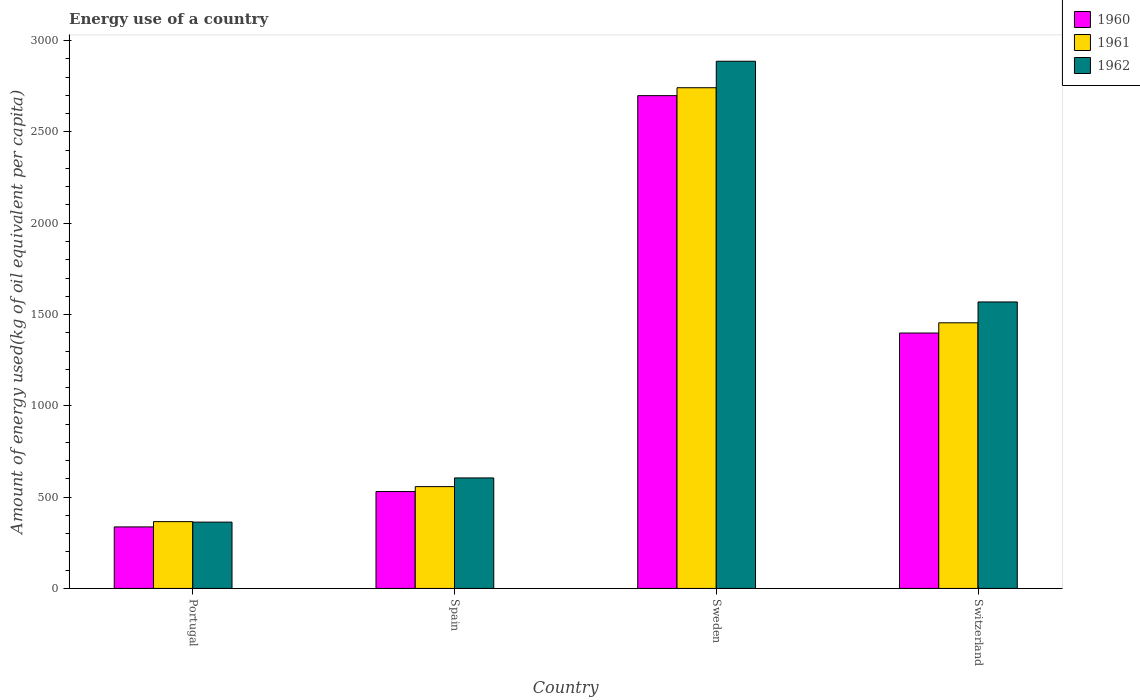What is the label of the 3rd group of bars from the left?
Offer a terse response. Sweden. In how many cases, is the number of bars for a given country not equal to the number of legend labels?
Keep it short and to the point. 0. What is the amount of energy used in in 1962 in Sweden?
Your answer should be compact. 2887.24. Across all countries, what is the maximum amount of energy used in in 1961?
Provide a succinct answer. 2742.12. Across all countries, what is the minimum amount of energy used in in 1961?
Keep it short and to the point. 365.84. What is the total amount of energy used in in 1962 in the graph?
Your answer should be compact. 5424.53. What is the difference between the amount of energy used in in 1960 in Portugal and that in Spain?
Your answer should be compact. -193.75. What is the difference between the amount of energy used in in 1960 in Sweden and the amount of energy used in in 1961 in Spain?
Your answer should be very brief. 2141.19. What is the average amount of energy used in in 1962 per country?
Give a very brief answer. 1356.13. What is the difference between the amount of energy used in of/in 1962 and amount of energy used in of/in 1960 in Portugal?
Your response must be concise. 26.25. In how many countries, is the amount of energy used in in 1960 greater than 2100 kg?
Your response must be concise. 1. What is the ratio of the amount of energy used in in 1962 in Spain to that in Switzerland?
Provide a succinct answer. 0.39. What is the difference between the highest and the second highest amount of energy used in in 1961?
Offer a very short reply. 897.16. What is the difference between the highest and the lowest amount of energy used in in 1960?
Provide a short and direct response. 2361.88. In how many countries, is the amount of energy used in in 1961 greater than the average amount of energy used in in 1961 taken over all countries?
Make the answer very short. 2. Is the sum of the amount of energy used in in 1962 in Portugal and Switzerland greater than the maximum amount of energy used in in 1961 across all countries?
Provide a succinct answer. No. What does the 2nd bar from the right in Spain represents?
Your answer should be very brief. 1961. Are all the bars in the graph horizontal?
Offer a very short reply. No. How many countries are there in the graph?
Offer a very short reply. 4. What is the difference between two consecutive major ticks on the Y-axis?
Provide a short and direct response. 500. Are the values on the major ticks of Y-axis written in scientific E-notation?
Provide a short and direct response. No. Does the graph contain grids?
Keep it short and to the point. No. How many legend labels are there?
Your answer should be compact. 3. How are the legend labels stacked?
Ensure brevity in your answer.  Vertical. What is the title of the graph?
Your response must be concise. Energy use of a country. Does "1968" appear as one of the legend labels in the graph?
Make the answer very short. No. What is the label or title of the X-axis?
Keep it short and to the point. Country. What is the label or title of the Y-axis?
Provide a succinct answer. Amount of energy used(kg of oil equivalent per capita). What is the Amount of energy used(kg of oil equivalent per capita) in 1960 in Portugal?
Your response must be concise. 336.91. What is the Amount of energy used(kg of oil equivalent per capita) of 1961 in Portugal?
Your answer should be compact. 365.84. What is the Amount of energy used(kg of oil equivalent per capita) of 1962 in Portugal?
Your response must be concise. 363.16. What is the Amount of energy used(kg of oil equivalent per capita) of 1960 in Spain?
Provide a succinct answer. 530.66. What is the Amount of energy used(kg of oil equivalent per capita) in 1961 in Spain?
Your response must be concise. 557.6. What is the Amount of energy used(kg of oil equivalent per capita) of 1962 in Spain?
Your answer should be compact. 605.22. What is the Amount of energy used(kg of oil equivalent per capita) of 1960 in Sweden?
Give a very brief answer. 2698.79. What is the Amount of energy used(kg of oil equivalent per capita) in 1961 in Sweden?
Offer a very short reply. 2742.12. What is the Amount of energy used(kg of oil equivalent per capita) of 1962 in Sweden?
Offer a terse response. 2887.24. What is the Amount of energy used(kg of oil equivalent per capita) in 1960 in Switzerland?
Offer a terse response. 1398.65. What is the Amount of energy used(kg of oil equivalent per capita) in 1961 in Switzerland?
Your answer should be very brief. 1454.76. What is the Amount of energy used(kg of oil equivalent per capita) in 1962 in Switzerland?
Keep it short and to the point. 1568.91. Across all countries, what is the maximum Amount of energy used(kg of oil equivalent per capita) of 1960?
Offer a very short reply. 2698.79. Across all countries, what is the maximum Amount of energy used(kg of oil equivalent per capita) in 1961?
Give a very brief answer. 2742.12. Across all countries, what is the maximum Amount of energy used(kg of oil equivalent per capita) of 1962?
Your response must be concise. 2887.24. Across all countries, what is the minimum Amount of energy used(kg of oil equivalent per capita) in 1960?
Your answer should be compact. 336.91. Across all countries, what is the minimum Amount of energy used(kg of oil equivalent per capita) in 1961?
Make the answer very short. 365.84. Across all countries, what is the minimum Amount of energy used(kg of oil equivalent per capita) in 1962?
Give a very brief answer. 363.16. What is the total Amount of energy used(kg of oil equivalent per capita) in 1960 in the graph?
Give a very brief answer. 4965.03. What is the total Amount of energy used(kg of oil equivalent per capita) in 1961 in the graph?
Make the answer very short. 5120.32. What is the total Amount of energy used(kg of oil equivalent per capita) in 1962 in the graph?
Offer a very short reply. 5424.53. What is the difference between the Amount of energy used(kg of oil equivalent per capita) in 1960 in Portugal and that in Spain?
Provide a short and direct response. -193.75. What is the difference between the Amount of energy used(kg of oil equivalent per capita) in 1961 in Portugal and that in Spain?
Provide a short and direct response. -191.76. What is the difference between the Amount of energy used(kg of oil equivalent per capita) of 1962 in Portugal and that in Spain?
Give a very brief answer. -242.06. What is the difference between the Amount of energy used(kg of oil equivalent per capita) of 1960 in Portugal and that in Sweden?
Give a very brief answer. -2361.88. What is the difference between the Amount of energy used(kg of oil equivalent per capita) of 1961 in Portugal and that in Sweden?
Offer a very short reply. -2376.28. What is the difference between the Amount of energy used(kg of oil equivalent per capita) of 1962 in Portugal and that in Sweden?
Give a very brief answer. -2524.07. What is the difference between the Amount of energy used(kg of oil equivalent per capita) of 1960 in Portugal and that in Switzerland?
Keep it short and to the point. -1061.74. What is the difference between the Amount of energy used(kg of oil equivalent per capita) in 1961 in Portugal and that in Switzerland?
Offer a terse response. -1088.91. What is the difference between the Amount of energy used(kg of oil equivalent per capita) of 1962 in Portugal and that in Switzerland?
Ensure brevity in your answer.  -1205.75. What is the difference between the Amount of energy used(kg of oil equivalent per capita) of 1960 in Spain and that in Sweden?
Your response must be concise. -2168.13. What is the difference between the Amount of energy used(kg of oil equivalent per capita) in 1961 in Spain and that in Sweden?
Provide a short and direct response. -2184.52. What is the difference between the Amount of energy used(kg of oil equivalent per capita) in 1962 in Spain and that in Sweden?
Offer a terse response. -2282.01. What is the difference between the Amount of energy used(kg of oil equivalent per capita) in 1960 in Spain and that in Switzerland?
Ensure brevity in your answer.  -867.99. What is the difference between the Amount of energy used(kg of oil equivalent per capita) in 1961 in Spain and that in Switzerland?
Ensure brevity in your answer.  -897.16. What is the difference between the Amount of energy used(kg of oil equivalent per capita) of 1962 in Spain and that in Switzerland?
Offer a very short reply. -963.69. What is the difference between the Amount of energy used(kg of oil equivalent per capita) of 1960 in Sweden and that in Switzerland?
Provide a short and direct response. 1300.14. What is the difference between the Amount of energy used(kg of oil equivalent per capita) of 1961 in Sweden and that in Switzerland?
Ensure brevity in your answer.  1287.37. What is the difference between the Amount of energy used(kg of oil equivalent per capita) of 1962 in Sweden and that in Switzerland?
Offer a terse response. 1318.33. What is the difference between the Amount of energy used(kg of oil equivalent per capita) in 1960 in Portugal and the Amount of energy used(kg of oil equivalent per capita) in 1961 in Spain?
Provide a short and direct response. -220.69. What is the difference between the Amount of energy used(kg of oil equivalent per capita) of 1960 in Portugal and the Amount of energy used(kg of oil equivalent per capita) of 1962 in Spain?
Your answer should be very brief. -268.31. What is the difference between the Amount of energy used(kg of oil equivalent per capita) in 1961 in Portugal and the Amount of energy used(kg of oil equivalent per capita) in 1962 in Spain?
Your answer should be compact. -239.38. What is the difference between the Amount of energy used(kg of oil equivalent per capita) in 1960 in Portugal and the Amount of energy used(kg of oil equivalent per capita) in 1961 in Sweden?
Give a very brief answer. -2405.21. What is the difference between the Amount of energy used(kg of oil equivalent per capita) of 1960 in Portugal and the Amount of energy used(kg of oil equivalent per capita) of 1962 in Sweden?
Your answer should be very brief. -2550.32. What is the difference between the Amount of energy used(kg of oil equivalent per capita) in 1961 in Portugal and the Amount of energy used(kg of oil equivalent per capita) in 1962 in Sweden?
Provide a succinct answer. -2521.4. What is the difference between the Amount of energy used(kg of oil equivalent per capita) in 1960 in Portugal and the Amount of energy used(kg of oil equivalent per capita) in 1961 in Switzerland?
Offer a terse response. -1117.84. What is the difference between the Amount of energy used(kg of oil equivalent per capita) of 1960 in Portugal and the Amount of energy used(kg of oil equivalent per capita) of 1962 in Switzerland?
Keep it short and to the point. -1232. What is the difference between the Amount of energy used(kg of oil equivalent per capita) in 1961 in Portugal and the Amount of energy used(kg of oil equivalent per capita) in 1962 in Switzerland?
Offer a very short reply. -1203.07. What is the difference between the Amount of energy used(kg of oil equivalent per capita) in 1960 in Spain and the Amount of energy used(kg of oil equivalent per capita) in 1961 in Sweden?
Give a very brief answer. -2211.46. What is the difference between the Amount of energy used(kg of oil equivalent per capita) in 1960 in Spain and the Amount of energy used(kg of oil equivalent per capita) in 1962 in Sweden?
Offer a terse response. -2356.57. What is the difference between the Amount of energy used(kg of oil equivalent per capita) of 1961 in Spain and the Amount of energy used(kg of oil equivalent per capita) of 1962 in Sweden?
Give a very brief answer. -2329.64. What is the difference between the Amount of energy used(kg of oil equivalent per capita) in 1960 in Spain and the Amount of energy used(kg of oil equivalent per capita) in 1961 in Switzerland?
Your answer should be compact. -924.09. What is the difference between the Amount of energy used(kg of oil equivalent per capita) of 1960 in Spain and the Amount of energy used(kg of oil equivalent per capita) of 1962 in Switzerland?
Keep it short and to the point. -1038.25. What is the difference between the Amount of energy used(kg of oil equivalent per capita) of 1961 in Spain and the Amount of energy used(kg of oil equivalent per capita) of 1962 in Switzerland?
Your answer should be compact. -1011.31. What is the difference between the Amount of energy used(kg of oil equivalent per capita) of 1960 in Sweden and the Amount of energy used(kg of oil equivalent per capita) of 1961 in Switzerland?
Your response must be concise. 1244.04. What is the difference between the Amount of energy used(kg of oil equivalent per capita) of 1960 in Sweden and the Amount of energy used(kg of oil equivalent per capita) of 1962 in Switzerland?
Your answer should be very brief. 1129.88. What is the difference between the Amount of energy used(kg of oil equivalent per capita) in 1961 in Sweden and the Amount of energy used(kg of oil equivalent per capita) in 1962 in Switzerland?
Provide a succinct answer. 1173.21. What is the average Amount of energy used(kg of oil equivalent per capita) of 1960 per country?
Your response must be concise. 1241.26. What is the average Amount of energy used(kg of oil equivalent per capita) in 1961 per country?
Ensure brevity in your answer.  1280.08. What is the average Amount of energy used(kg of oil equivalent per capita) of 1962 per country?
Provide a short and direct response. 1356.13. What is the difference between the Amount of energy used(kg of oil equivalent per capita) in 1960 and Amount of energy used(kg of oil equivalent per capita) in 1961 in Portugal?
Your answer should be compact. -28.93. What is the difference between the Amount of energy used(kg of oil equivalent per capita) in 1960 and Amount of energy used(kg of oil equivalent per capita) in 1962 in Portugal?
Keep it short and to the point. -26.25. What is the difference between the Amount of energy used(kg of oil equivalent per capita) of 1961 and Amount of energy used(kg of oil equivalent per capita) of 1962 in Portugal?
Give a very brief answer. 2.68. What is the difference between the Amount of energy used(kg of oil equivalent per capita) of 1960 and Amount of energy used(kg of oil equivalent per capita) of 1961 in Spain?
Your response must be concise. -26.93. What is the difference between the Amount of energy used(kg of oil equivalent per capita) of 1960 and Amount of energy used(kg of oil equivalent per capita) of 1962 in Spain?
Give a very brief answer. -74.56. What is the difference between the Amount of energy used(kg of oil equivalent per capita) in 1961 and Amount of energy used(kg of oil equivalent per capita) in 1962 in Spain?
Provide a short and direct response. -47.62. What is the difference between the Amount of energy used(kg of oil equivalent per capita) of 1960 and Amount of energy used(kg of oil equivalent per capita) of 1961 in Sweden?
Offer a terse response. -43.33. What is the difference between the Amount of energy used(kg of oil equivalent per capita) of 1960 and Amount of energy used(kg of oil equivalent per capita) of 1962 in Sweden?
Your answer should be compact. -188.44. What is the difference between the Amount of energy used(kg of oil equivalent per capita) in 1961 and Amount of energy used(kg of oil equivalent per capita) in 1962 in Sweden?
Offer a very short reply. -145.11. What is the difference between the Amount of energy used(kg of oil equivalent per capita) in 1960 and Amount of energy used(kg of oil equivalent per capita) in 1961 in Switzerland?
Give a very brief answer. -56.1. What is the difference between the Amount of energy used(kg of oil equivalent per capita) in 1960 and Amount of energy used(kg of oil equivalent per capita) in 1962 in Switzerland?
Your answer should be very brief. -170.26. What is the difference between the Amount of energy used(kg of oil equivalent per capita) of 1961 and Amount of energy used(kg of oil equivalent per capita) of 1962 in Switzerland?
Your answer should be very brief. -114.16. What is the ratio of the Amount of energy used(kg of oil equivalent per capita) of 1960 in Portugal to that in Spain?
Give a very brief answer. 0.63. What is the ratio of the Amount of energy used(kg of oil equivalent per capita) of 1961 in Portugal to that in Spain?
Offer a very short reply. 0.66. What is the ratio of the Amount of energy used(kg of oil equivalent per capita) of 1962 in Portugal to that in Spain?
Your answer should be compact. 0.6. What is the ratio of the Amount of energy used(kg of oil equivalent per capita) of 1960 in Portugal to that in Sweden?
Give a very brief answer. 0.12. What is the ratio of the Amount of energy used(kg of oil equivalent per capita) of 1961 in Portugal to that in Sweden?
Your answer should be very brief. 0.13. What is the ratio of the Amount of energy used(kg of oil equivalent per capita) of 1962 in Portugal to that in Sweden?
Give a very brief answer. 0.13. What is the ratio of the Amount of energy used(kg of oil equivalent per capita) in 1960 in Portugal to that in Switzerland?
Ensure brevity in your answer.  0.24. What is the ratio of the Amount of energy used(kg of oil equivalent per capita) in 1961 in Portugal to that in Switzerland?
Make the answer very short. 0.25. What is the ratio of the Amount of energy used(kg of oil equivalent per capita) in 1962 in Portugal to that in Switzerland?
Your answer should be compact. 0.23. What is the ratio of the Amount of energy used(kg of oil equivalent per capita) in 1960 in Spain to that in Sweden?
Offer a very short reply. 0.2. What is the ratio of the Amount of energy used(kg of oil equivalent per capita) of 1961 in Spain to that in Sweden?
Offer a very short reply. 0.2. What is the ratio of the Amount of energy used(kg of oil equivalent per capita) in 1962 in Spain to that in Sweden?
Provide a short and direct response. 0.21. What is the ratio of the Amount of energy used(kg of oil equivalent per capita) of 1960 in Spain to that in Switzerland?
Give a very brief answer. 0.38. What is the ratio of the Amount of energy used(kg of oil equivalent per capita) of 1961 in Spain to that in Switzerland?
Provide a short and direct response. 0.38. What is the ratio of the Amount of energy used(kg of oil equivalent per capita) in 1962 in Spain to that in Switzerland?
Make the answer very short. 0.39. What is the ratio of the Amount of energy used(kg of oil equivalent per capita) in 1960 in Sweden to that in Switzerland?
Give a very brief answer. 1.93. What is the ratio of the Amount of energy used(kg of oil equivalent per capita) in 1961 in Sweden to that in Switzerland?
Offer a very short reply. 1.88. What is the ratio of the Amount of energy used(kg of oil equivalent per capita) of 1962 in Sweden to that in Switzerland?
Keep it short and to the point. 1.84. What is the difference between the highest and the second highest Amount of energy used(kg of oil equivalent per capita) in 1960?
Give a very brief answer. 1300.14. What is the difference between the highest and the second highest Amount of energy used(kg of oil equivalent per capita) in 1961?
Make the answer very short. 1287.37. What is the difference between the highest and the second highest Amount of energy used(kg of oil equivalent per capita) of 1962?
Offer a terse response. 1318.33. What is the difference between the highest and the lowest Amount of energy used(kg of oil equivalent per capita) in 1960?
Keep it short and to the point. 2361.88. What is the difference between the highest and the lowest Amount of energy used(kg of oil equivalent per capita) in 1961?
Your response must be concise. 2376.28. What is the difference between the highest and the lowest Amount of energy used(kg of oil equivalent per capita) of 1962?
Offer a very short reply. 2524.07. 